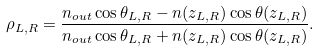Convert formula to latex. <formula><loc_0><loc_0><loc_500><loc_500>\rho _ { L , R } = \frac { n _ { o u t } \cos \theta _ { L , R } - n ( z _ { L , R } ) \cos \theta ( z _ { L , R } ) } { n _ { o u t } \cos \theta _ { L , R } + n ( z _ { L , R } ) \cos \theta ( z _ { L , R } ) } .</formula> 